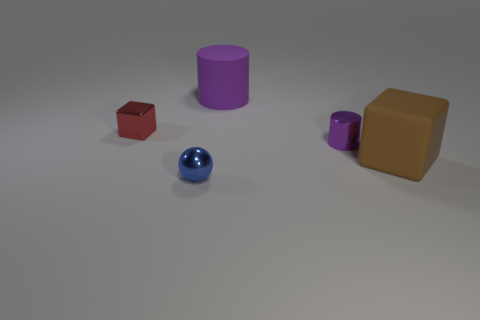Add 3 small blocks. How many objects exist? 8 Subtract all cylinders. How many objects are left? 3 Subtract 1 balls. How many balls are left? 0 Subtract all cyan cylinders. Subtract all brown balls. How many cylinders are left? 2 Subtract all green spheres. How many brown blocks are left? 1 Subtract all green spheres. Subtract all small purple cylinders. How many objects are left? 4 Add 3 small red shiny things. How many small red shiny things are left? 4 Add 5 small yellow matte cylinders. How many small yellow matte cylinders exist? 5 Subtract 1 red blocks. How many objects are left? 4 